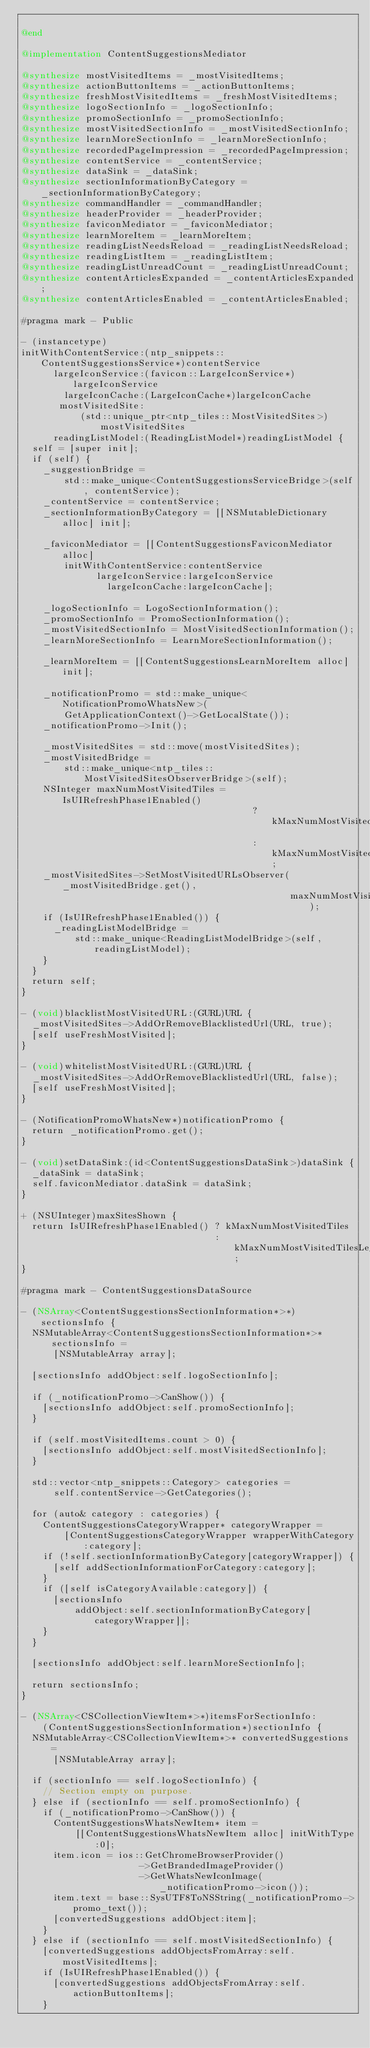Convert code to text. <code><loc_0><loc_0><loc_500><loc_500><_ObjectiveC_>
@end

@implementation ContentSuggestionsMediator

@synthesize mostVisitedItems = _mostVisitedItems;
@synthesize actionButtonItems = _actionButtonItems;
@synthesize freshMostVisitedItems = _freshMostVisitedItems;
@synthesize logoSectionInfo = _logoSectionInfo;
@synthesize promoSectionInfo = _promoSectionInfo;
@synthesize mostVisitedSectionInfo = _mostVisitedSectionInfo;
@synthesize learnMoreSectionInfo = _learnMoreSectionInfo;
@synthesize recordedPageImpression = _recordedPageImpression;
@synthesize contentService = _contentService;
@synthesize dataSink = _dataSink;
@synthesize sectionInformationByCategory = _sectionInformationByCategory;
@synthesize commandHandler = _commandHandler;
@synthesize headerProvider = _headerProvider;
@synthesize faviconMediator = _faviconMediator;
@synthesize learnMoreItem = _learnMoreItem;
@synthesize readingListNeedsReload = _readingListNeedsReload;
@synthesize readingListItem = _readingListItem;
@synthesize readingListUnreadCount = _readingListUnreadCount;
@synthesize contentArticlesExpanded = _contentArticlesExpanded;
@synthesize contentArticlesEnabled = _contentArticlesEnabled;

#pragma mark - Public

- (instancetype)
initWithContentService:(ntp_snippets::ContentSuggestionsService*)contentService
      largeIconService:(favicon::LargeIconService*)largeIconService
        largeIconCache:(LargeIconCache*)largeIconCache
       mostVisitedSite:
           (std::unique_ptr<ntp_tiles::MostVisitedSites>)mostVisitedSites
      readingListModel:(ReadingListModel*)readingListModel {
  self = [super init];
  if (self) {
    _suggestionBridge =
        std::make_unique<ContentSuggestionsServiceBridge>(self, contentService);
    _contentService = contentService;
    _sectionInformationByCategory = [[NSMutableDictionary alloc] init];

    _faviconMediator = [[ContentSuggestionsFaviconMediator alloc]
        initWithContentService:contentService
              largeIconService:largeIconService
                largeIconCache:largeIconCache];

    _logoSectionInfo = LogoSectionInformation();
    _promoSectionInfo = PromoSectionInformation();
    _mostVisitedSectionInfo = MostVisitedSectionInformation();
    _learnMoreSectionInfo = LearnMoreSectionInformation();

    _learnMoreItem = [[ContentSuggestionsLearnMoreItem alloc] init];

    _notificationPromo = std::make_unique<NotificationPromoWhatsNew>(
        GetApplicationContext()->GetLocalState());
    _notificationPromo->Init();

    _mostVisitedSites = std::move(mostVisitedSites);
    _mostVisitedBridge =
        std::make_unique<ntp_tiles::MostVisitedSitesObserverBridge>(self);
    NSInteger maxNumMostVisitedTiles = IsUIRefreshPhase1Enabled()
                                           ? kMaxNumMostVisitedTiles
                                           : kMaxNumMostVisitedTilesLegacy;
    _mostVisitedSites->SetMostVisitedURLsObserver(_mostVisitedBridge.get(),
                                                  maxNumMostVisitedTiles);
    if (IsUIRefreshPhase1Enabled()) {
      _readingListModelBridge =
          std::make_unique<ReadingListModelBridge>(self, readingListModel);
    }
  }
  return self;
}

- (void)blacklistMostVisitedURL:(GURL)URL {
  _mostVisitedSites->AddOrRemoveBlacklistedUrl(URL, true);
  [self useFreshMostVisited];
}

- (void)whitelistMostVisitedURL:(GURL)URL {
  _mostVisitedSites->AddOrRemoveBlacklistedUrl(URL, false);
  [self useFreshMostVisited];
}

- (NotificationPromoWhatsNew*)notificationPromo {
  return _notificationPromo.get();
}

- (void)setDataSink:(id<ContentSuggestionsDataSink>)dataSink {
  _dataSink = dataSink;
  self.faviconMediator.dataSink = dataSink;
}

+ (NSUInteger)maxSitesShown {
  return IsUIRefreshPhase1Enabled() ? kMaxNumMostVisitedTiles
                                    : kMaxNumMostVisitedTilesLegacy;
}

#pragma mark - ContentSuggestionsDataSource

- (NSArray<ContentSuggestionsSectionInformation*>*)sectionsInfo {
  NSMutableArray<ContentSuggestionsSectionInformation*>* sectionsInfo =
      [NSMutableArray array];

  [sectionsInfo addObject:self.logoSectionInfo];

  if (_notificationPromo->CanShow()) {
    [sectionsInfo addObject:self.promoSectionInfo];
  }

  if (self.mostVisitedItems.count > 0) {
    [sectionsInfo addObject:self.mostVisitedSectionInfo];
  }

  std::vector<ntp_snippets::Category> categories =
      self.contentService->GetCategories();

  for (auto& category : categories) {
    ContentSuggestionsCategoryWrapper* categoryWrapper =
        [ContentSuggestionsCategoryWrapper wrapperWithCategory:category];
    if (!self.sectionInformationByCategory[categoryWrapper]) {
      [self addSectionInformationForCategory:category];
    }
    if ([self isCategoryAvailable:category]) {
      [sectionsInfo
          addObject:self.sectionInformationByCategory[categoryWrapper]];
    }
  }

  [sectionsInfo addObject:self.learnMoreSectionInfo];

  return sectionsInfo;
}

- (NSArray<CSCollectionViewItem*>*)itemsForSectionInfo:
    (ContentSuggestionsSectionInformation*)sectionInfo {
  NSMutableArray<CSCollectionViewItem*>* convertedSuggestions =
      [NSMutableArray array];

  if (sectionInfo == self.logoSectionInfo) {
    // Section empty on purpose.
  } else if (sectionInfo == self.promoSectionInfo) {
    if (_notificationPromo->CanShow()) {
      ContentSuggestionsWhatsNewItem* item =
          [[ContentSuggestionsWhatsNewItem alloc] initWithType:0];
      item.icon = ios::GetChromeBrowserProvider()
                      ->GetBrandedImageProvider()
                      ->GetWhatsNewIconImage(_notificationPromo->icon());
      item.text = base::SysUTF8ToNSString(_notificationPromo->promo_text());
      [convertedSuggestions addObject:item];
    }
  } else if (sectionInfo == self.mostVisitedSectionInfo) {
    [convertedSuggestions addObjectsFromArray:self.mostVisitedItems];
    if (IsUIRefreshPhase1Enabled()) {
      [convertedSuggestions addObjectsFromArray:self.actionButtonItems];
    }</code> 